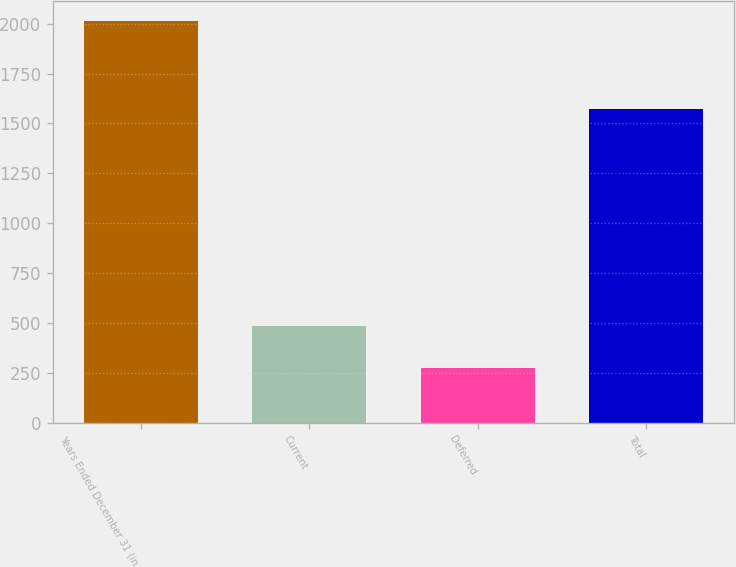Convert chart to OTSL. <chart><loc_0><loc_0><loc_500><loc_500><bar_chart><fcel>Years Ended December 31 (in<fcel>Current<fcel>Deferred<fcel>Total<nl><fcel>2012<fcel>484<fcel>275<fcel>1570<nl></chart> 